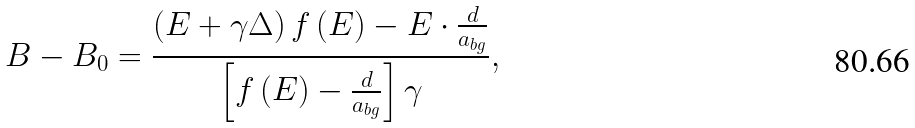<formula> <loc_0><loc_0><loc_500><loc_500>B - B _ { 0 } = \frac { \left ( E + \gamma \Delta \right ) f \left ( E \right ) - E \cdot \frac { d } { a _ { b g } } } { \left [ f \left ( E \right ) - \frac { d } { a _ { b g } } \right ] \gamma } ,</formula> 